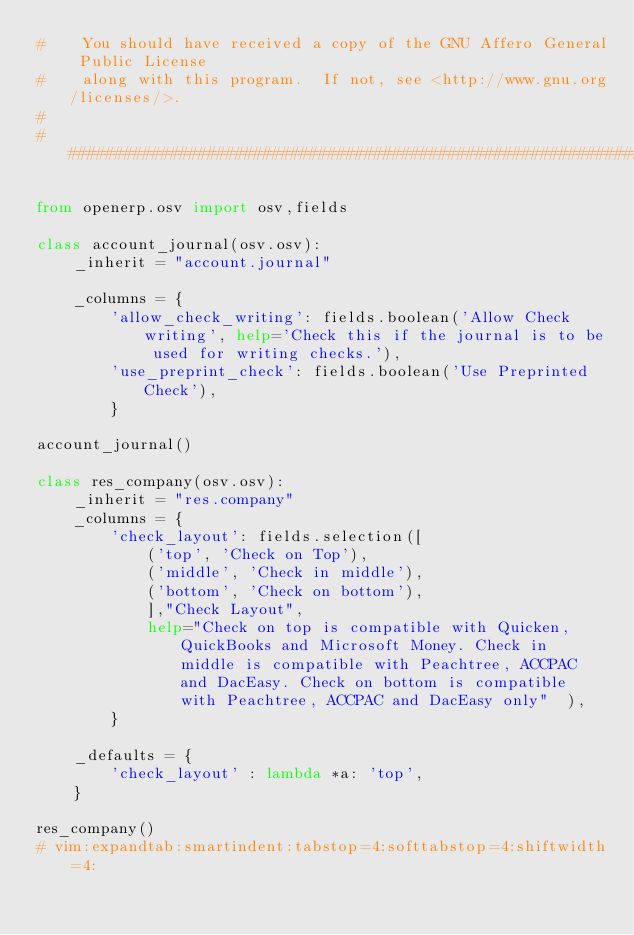<code> <loc_0><loc_0><loc_500><loc_500><_Python_>#    You should have received a copy of the GNU Affero General Public License
#    along with this program.  If not, see <http://www.gnu.org/licenses/>.
#
##############################################################################

from openerp.osv import osv,fields

class account_journal(osv.osv):
    _inherit = "account.journal"

    _columns = {
        'allow_check_writing': fields.boolean('Allow Check writing', help='Check this if the journal is to be used for writing checks.'),
        'use_preprint_check': fields.boolean('Use Preprinted Check'),
        }

account_journal()

class res_company(osv.osv):
    _inherit = "res.company"
    _columns = {
        'check_layout': fields.selection([
            ('top', 'Check on Top'),
            ('middle', 'Check in middle'),
            ('bottom', 'Check on bottom'),
            ],"Check Layout",
            help="Check on top is compatible with Quicken, QuickBooks and Microsoft Money. Check in middle is compatible with Peachtree, ACCPAC and DacEasy. Check on bottom is compatible with Peachtree, ACCPAC and DacEasy only"  ),
        }
        
    _defaults = {
        'check_layout' : lambda *a: 'top',
    }
    
res_company()
# vim:expandtab:smartindent:tabstop=4:softtabstop=4:shiftwidth=4:
</code> 